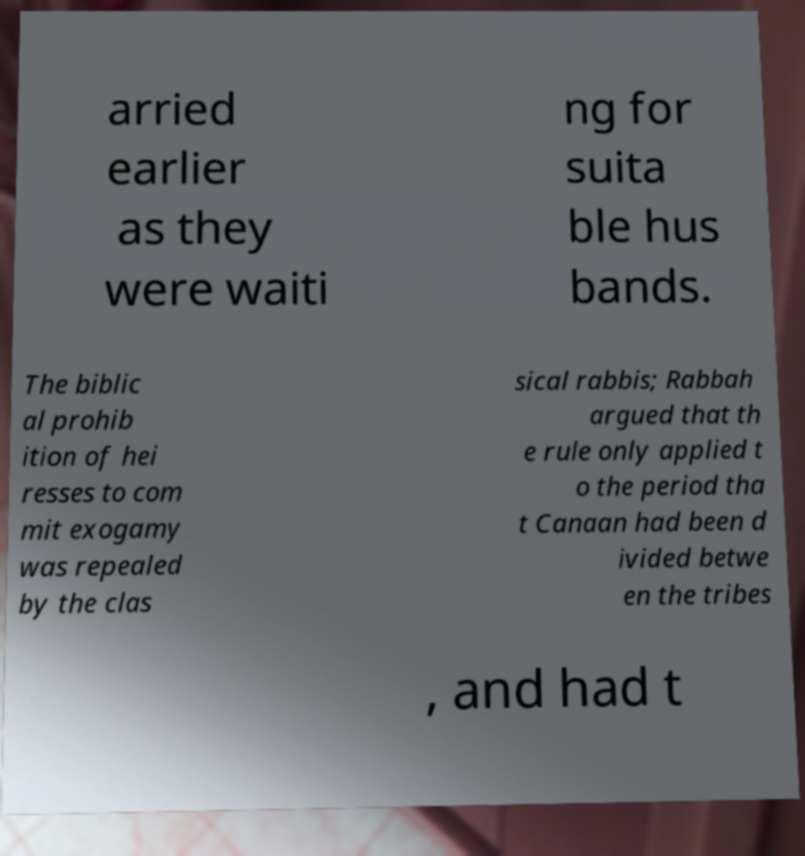Could you extract and type out the text from this image? arried earlier as they were waiti ng for suita ble hus bands. The biblic al prohib ition of hei resses to com mit exogamy was repealed by the clas sical rabbis; Rabbah argued that th e rule only applied t o the period tha t Canaan had been d ivided betwe en the tribes , and had t 